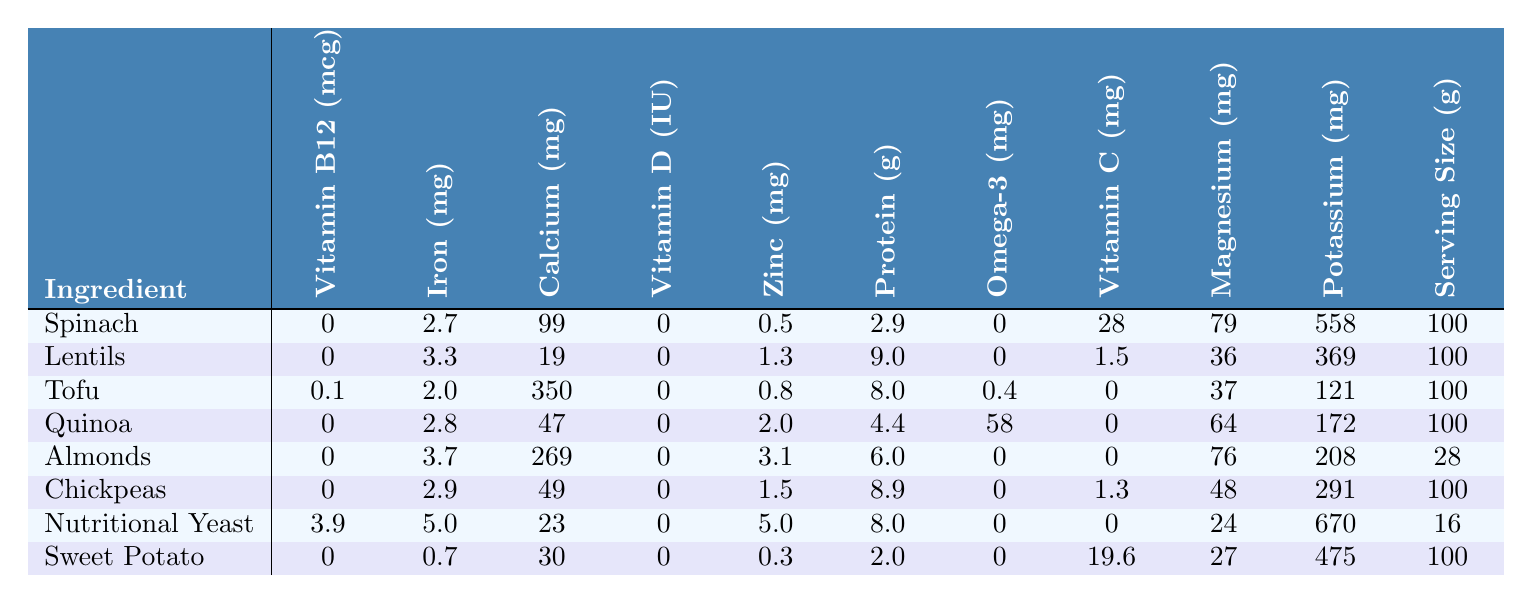What ingredient has the highest vitamin B12 content? By looking at the Vitamin B12 column, the highest value is 3.9 mcg, which corresponds to Nutritional Yeast.
Answer: Nutritional Yeast Which ingredient contains the most iron? In the Iron column, Nutritional Yeast has the highest value of 5.0 mg, indicating it contains the most iron compared to the others.
Answer: Nutritional Yeast What is the protein content of lentils? The Protein column shows that lentils have a protein content of 9.0 grams per 100 grams serving.
Answer: 9.0 grams What total amount of calcium do spinach and chickpeas provide together? Adding the calcium content from both ingredients, spinach has 99 mg and chickpeas have 49 mg, their total is 99 + 49 = 148 mg.
Answer: 148 mg Which two ingredients have the highest zinc content? The Zinc column shows that Nutritional Yeast has 5.0 mg and Almonds have 3.1 mg. Nutritional Yeast and Almonds are the two highest on the list.
Answer: Nutritional Yeast and Almonds What is the average potassium level among all ingredients? First, we sum the potassium values: 558 + 369 + 121 + 172 + 208 + 291 + 670 + 475 = 2364. Then, divide by the number of ingredients (8): 2364 / 8 = 295.5.
Answer: 295.5 mg Does any ingredient supply vitamin D? Reviewing the Vitamin D column, all values are 0, indicating no ingredient supplies vitamin D.
Answer: No Which ingredient provides the highest amount of omega-3? The Omega-3 column reveals that Quinoa has the most at 58 mg, making it the highest for omega-3 among the listed ingredients.
Answer: Quinoa How does the iron content of Tofu compare to that of Almonds? Tofu has 2.0 mg of iron while Almonds have 3.7 mg. Almonds have more iron than Tofu, specifically 1.7 mg more.
Answer: Almonds have more iron Which vegetarian ingredient has the least amount of calcium? By examining the Calcium column, Lentils have the least with 19 mg per 100 grams serving.
Answer: Lentils 